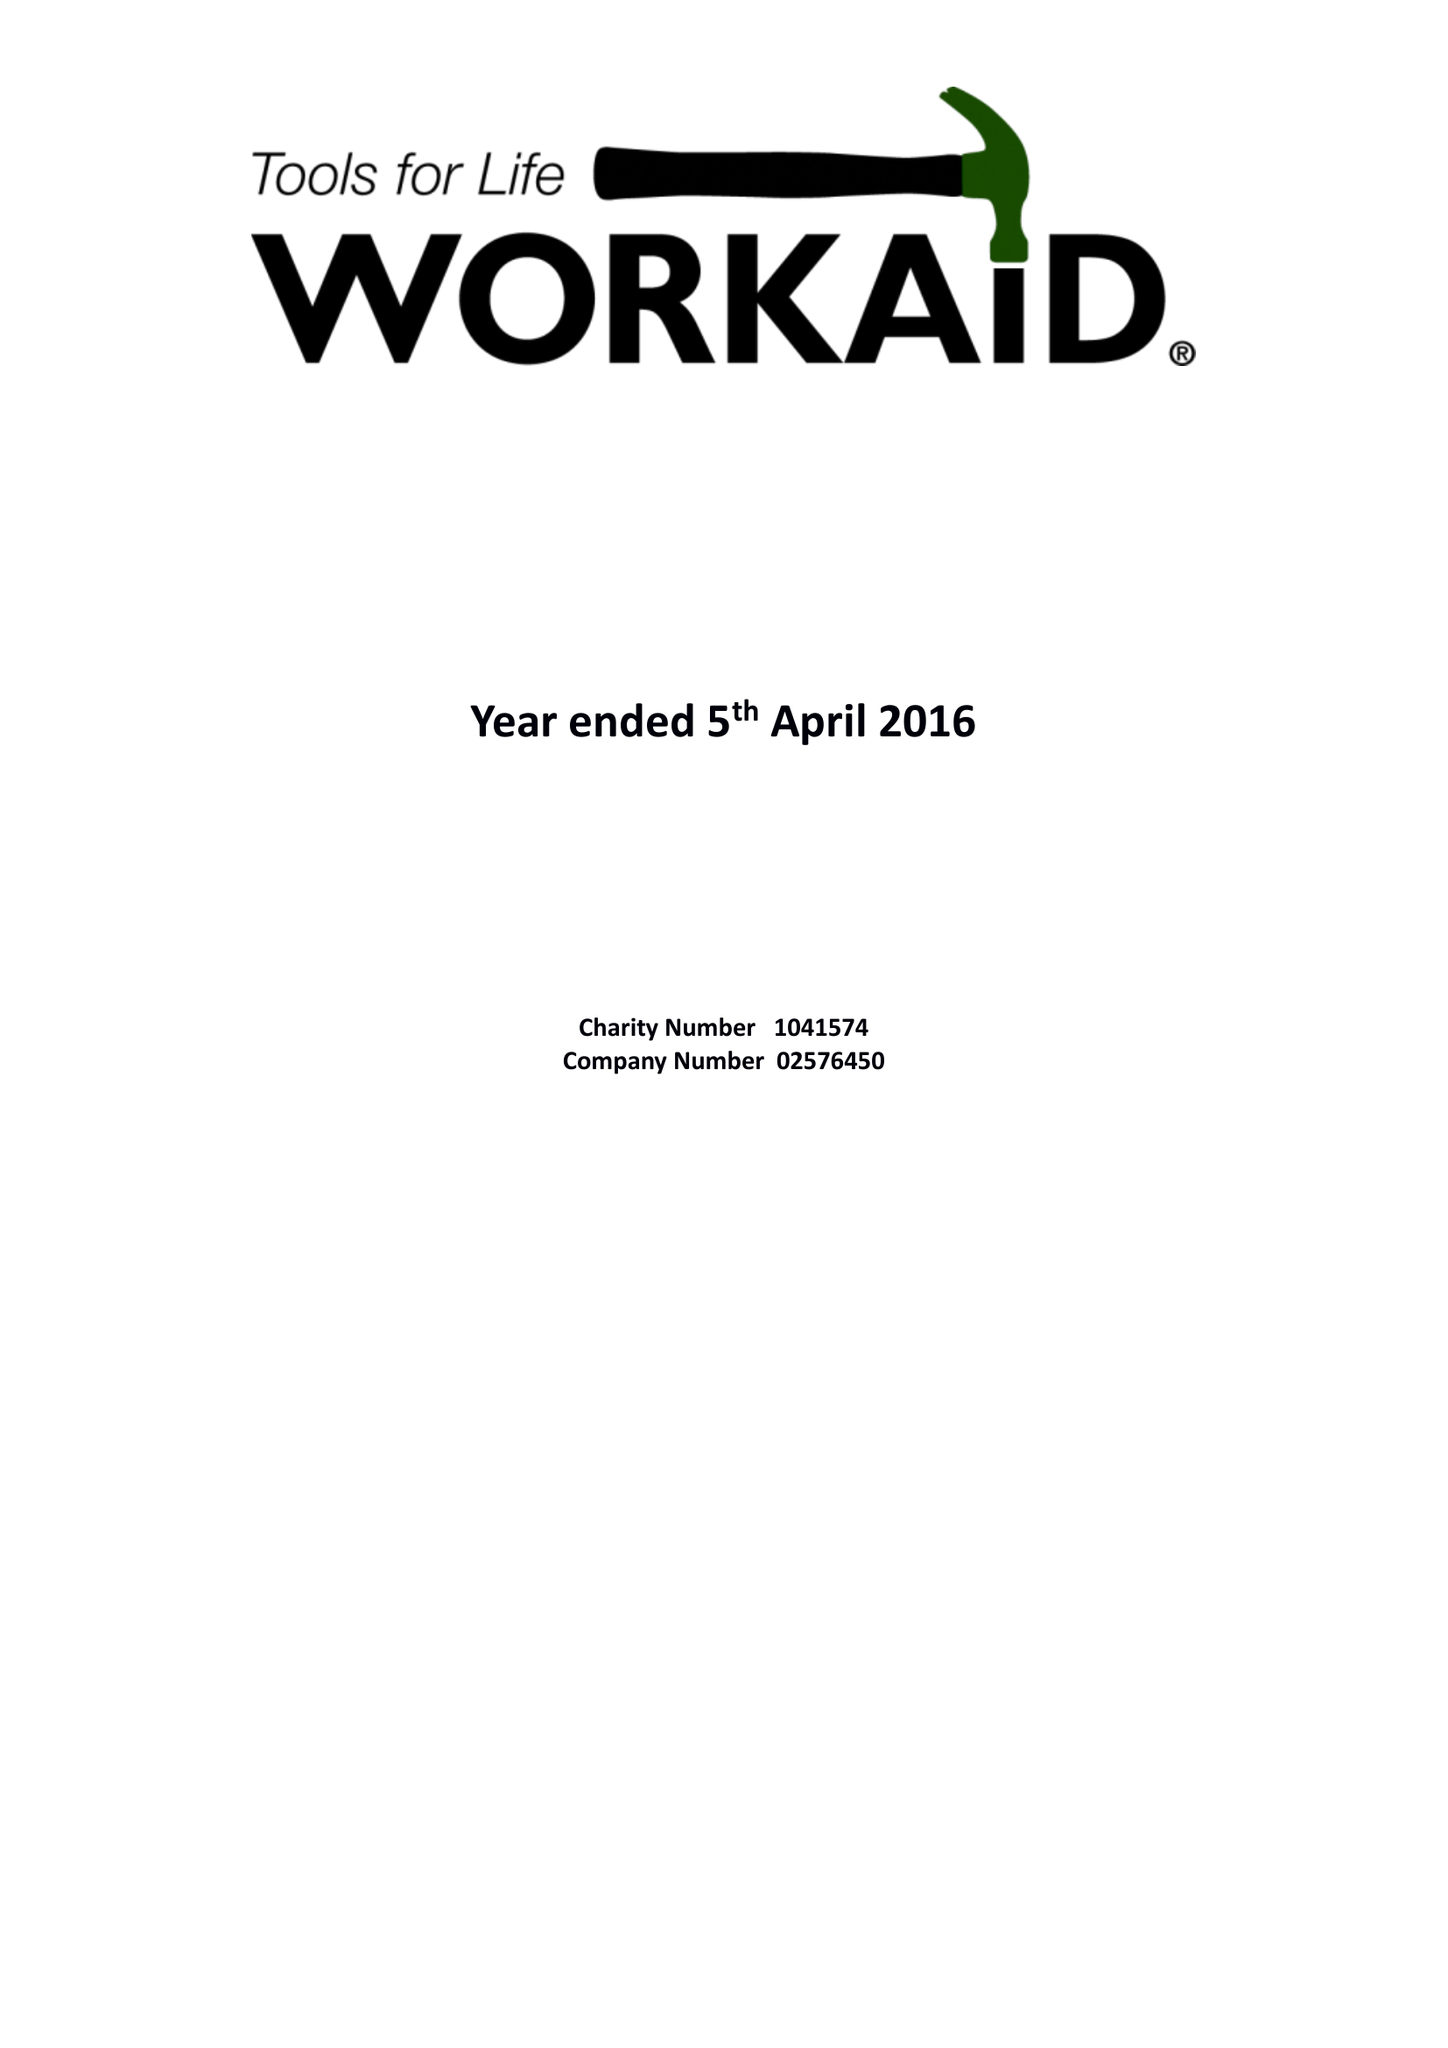What is the value for the spending_annually_in_british_pounds?
Answer the question using a single word or phrase. 264188.00 